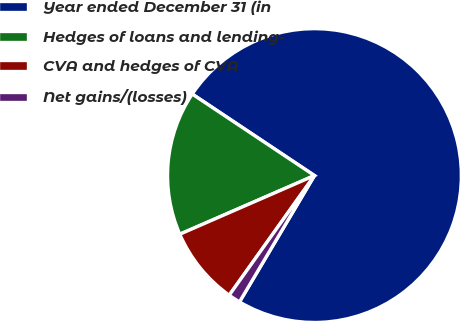Convert chart. <chart><loc_0><loc_0><loc_500><loc_500><pie_chart><fcel>Year ended December 31 (in<fcel>Hedges of loans and lending-<fcel>CVA and hedges of CVA<fcel>Net gains/(losses)<nl><fcel>74.17%<fcel>15.9%<fcel>8.61%<fcel>1.33%<nl></chart> 